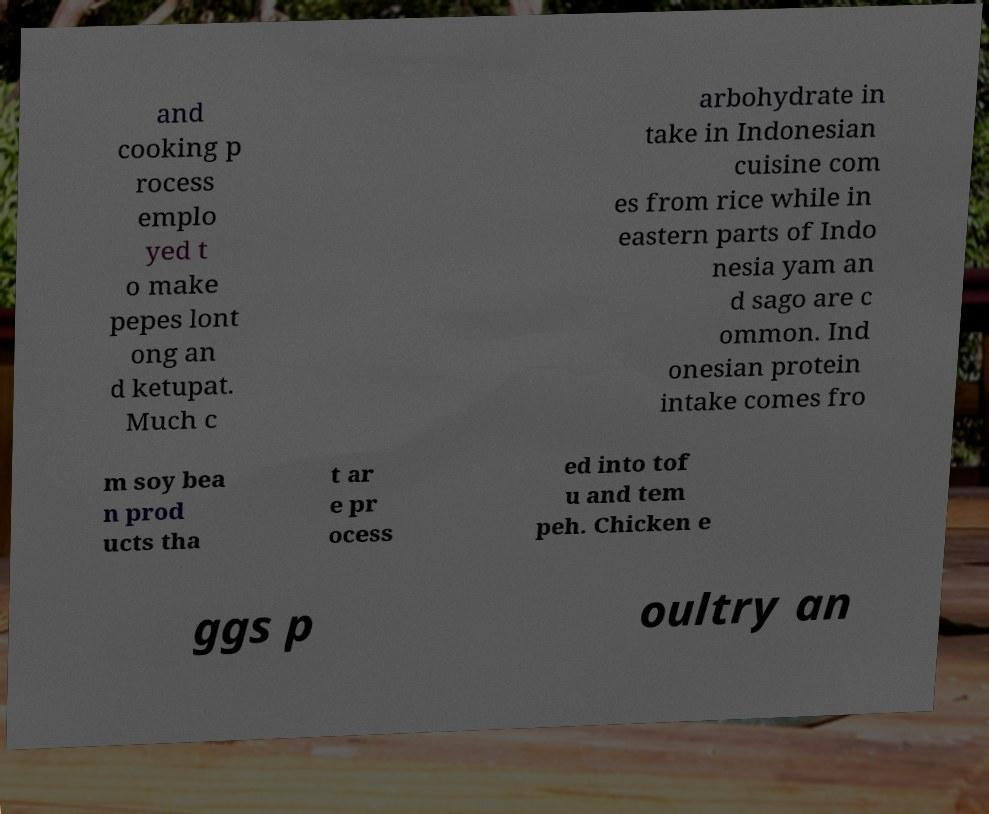For documentation purposes, I need the text within this image transcribed. Could you provide that? and cooking p rocess emplo yed t o make pepes lont ong an d ketupat. Much c arbohydrate in take in Indonesian cuisine com es from rice while in eastern parts of Indo nesia yam an d sago are c ommon. Ind onesian protein intake comes fro m soy bea n prod ucts tha t ar e pr ocess ed into tof u and tem peh. Chicken e ggs p oultry an 